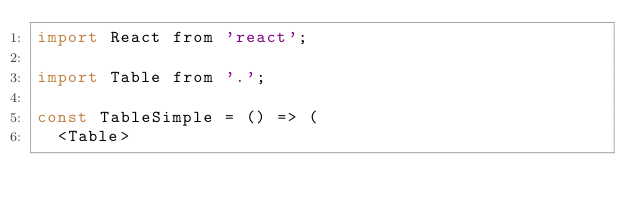Convert code to text. <code><loc_0><loc_0><loc_500><loc_500><_JavaScript_>import React from 'react';

import Table from '.';

const TableSimple = () => (
  <Table></code> 